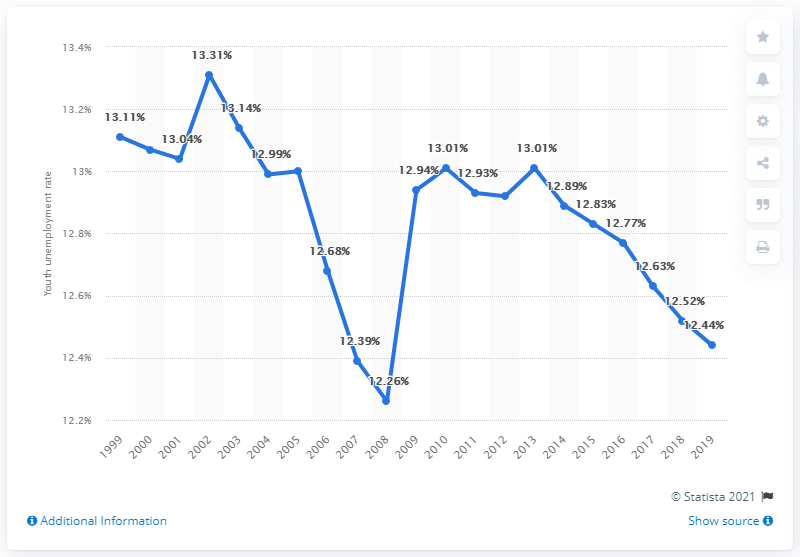Can you analyze the trend in youth unemployment in Gambia from 2001 to 2019? The trend in youth unemployment rates in Gambia from 2001 to 2019 shows some fluctuations. The rate started around 12.68% in 2001, peaked at 13.31% in 2002, then generally declined, reaching a low of 12.26% in 2007, and hovered around 13% from 2009 to 2016 before dropping to 12.44% in 2019. 